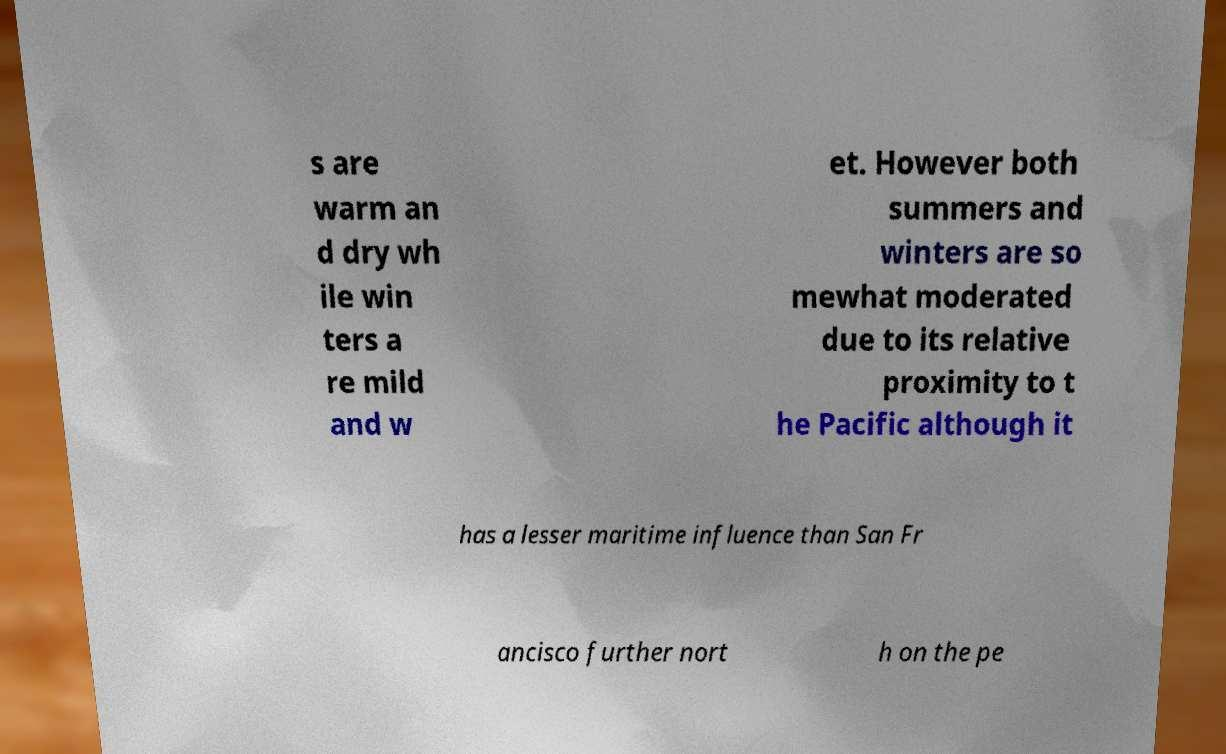Could you extract and type out the text from this image? s are warm an d dry wh ile win ters a re mild and w et. However both summers and winters are so mewhat moderated due to its relative proximity to t he Pacific although it has a lesser maritime influence than San Fr ancisco further nort h on the pe 